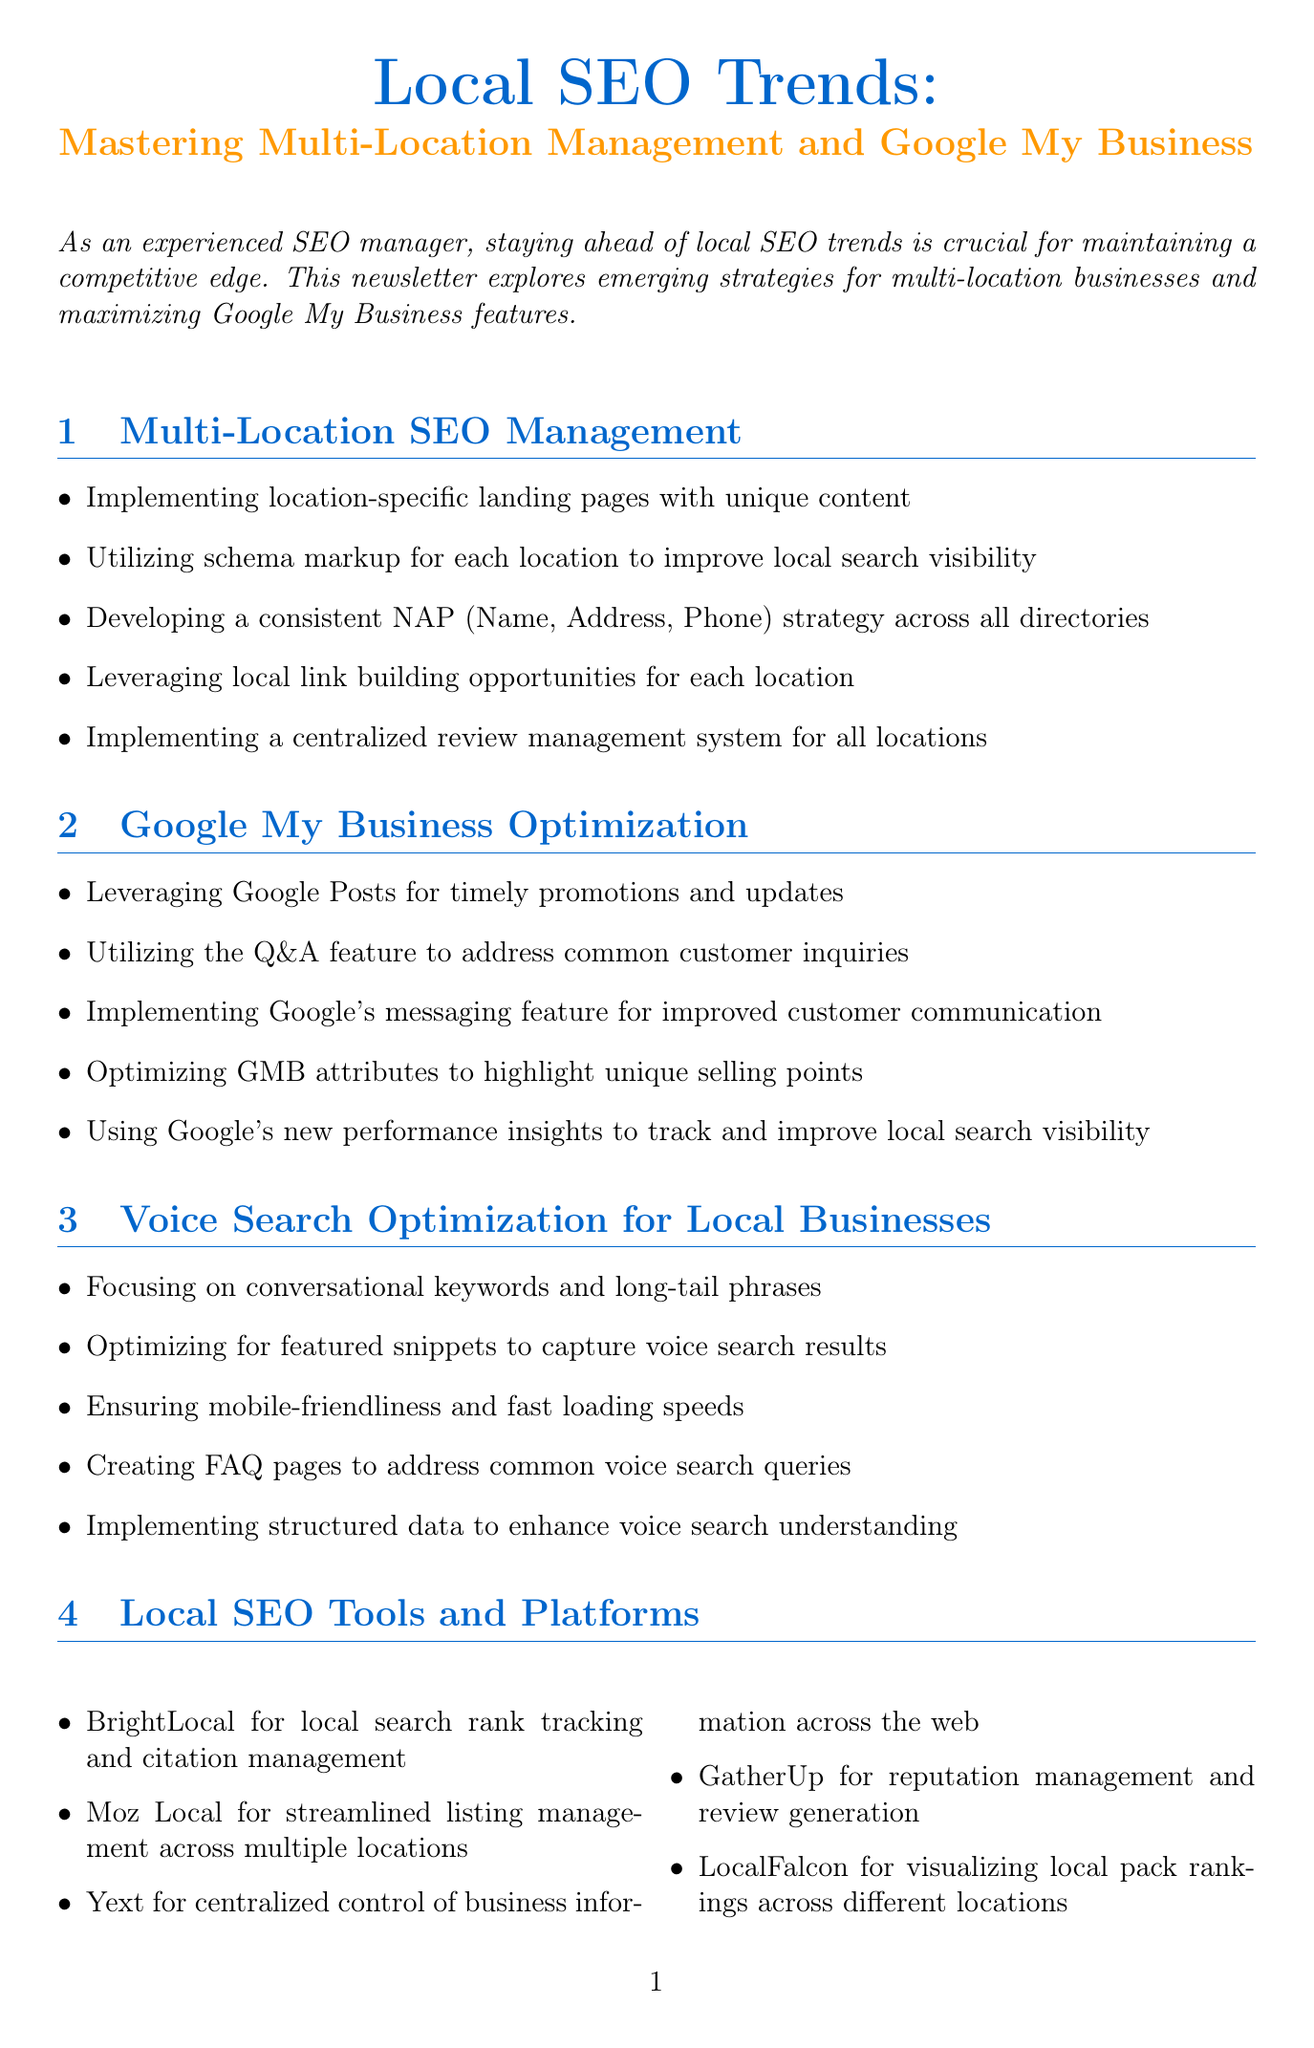What is the title of the newsletter? The title of the newsletter is prominently displayed at the beginning, making it clear.
Answer: Local SEO Trends: Mastering Multi-Location Management and Google My Business How many main sections are there in the newsletter? The document lists four main sections that cover key topics in local SEO.
Answer: Four What does NAP stand for? The document explains that NAP stands for Name, Address, Phone in the context of SEO.
Answer: Name, Address, Phone What percentage increase in organic search traffic did Domino's Pizza achieve? The case study provides specific results of the successful SEO strategy implemented by Domino's Pizza.
Answer: 43% Which tool is mentioned for reputation management? The document refers to several tools, and one specifically focuses on reputation management.
Answer: GatherUp What feature should be utilized to address common customer inquiries on Google My Business? The newsletter describes a specific feature that can help in managing customer questions effectively.
Answer: Q&A feature How often should local SEO audits be conducted for each location? The actionable tips section emphasizes the importance of regularity in audits.
Answer: Regularly What is one of the strategies for voice search optimization? The document outlines multiple strategies, one of which is focused on voice search.
Answer: Conversational keywords Which document section discusses local link building opportunities? By checking the main sections, we can identify which one mentions this topic.
Answer: Multi-Location SEO Management 